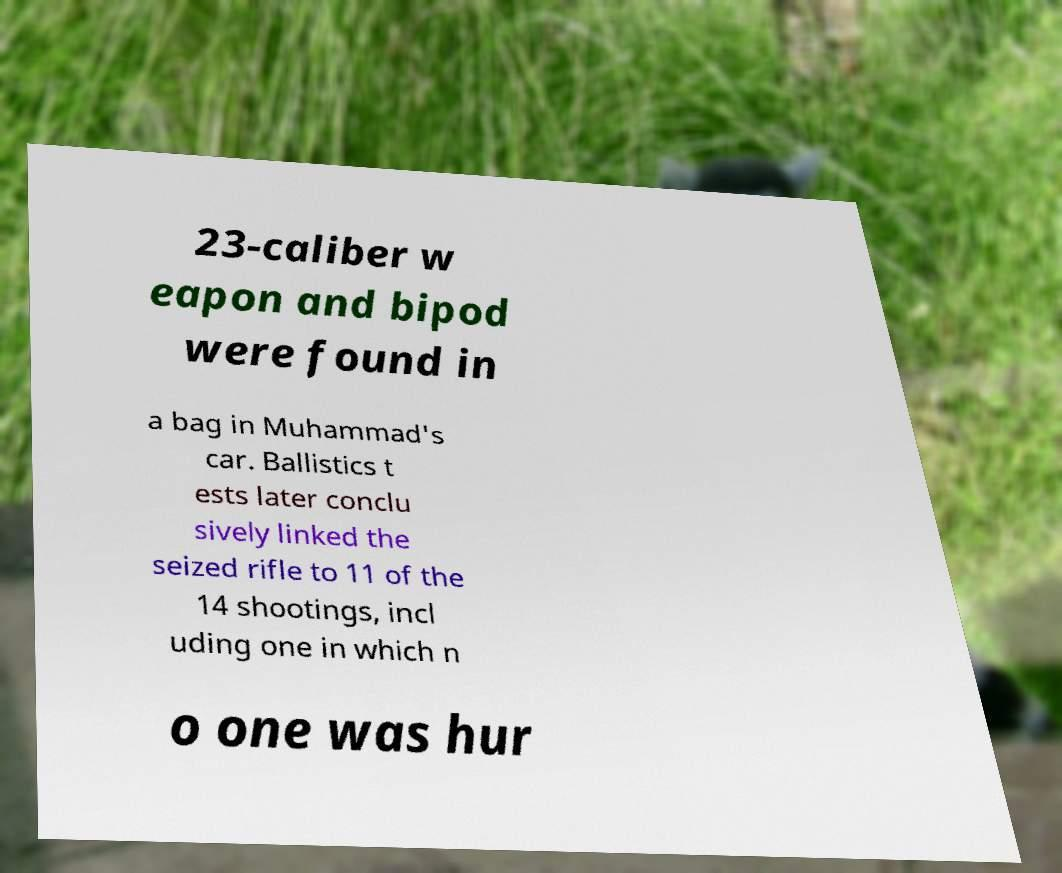Could you extract and type out the text from this image? 23-caliber w eapon and bipod were found in a bag in Muhammad's car. Ballistics t ests later conclu sively linked the seized rifle to 11 of the 14 shootings, incl uding one in which n o one was hur 